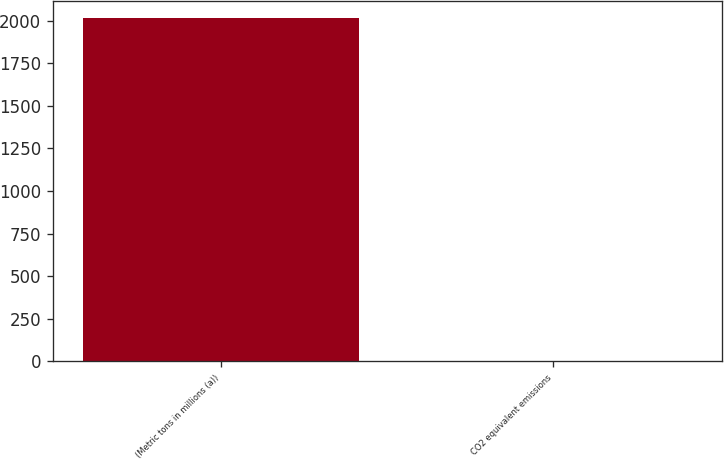Convert chart to OTSL. <chart><loc_0><loc_0><loc_500><loc_500><bar_chart><fcel>(Metric tons in millions (a))<fcel>CO2 equivalent emissions<nl><fcel>2016<fcel>3.1<nl></chart> 